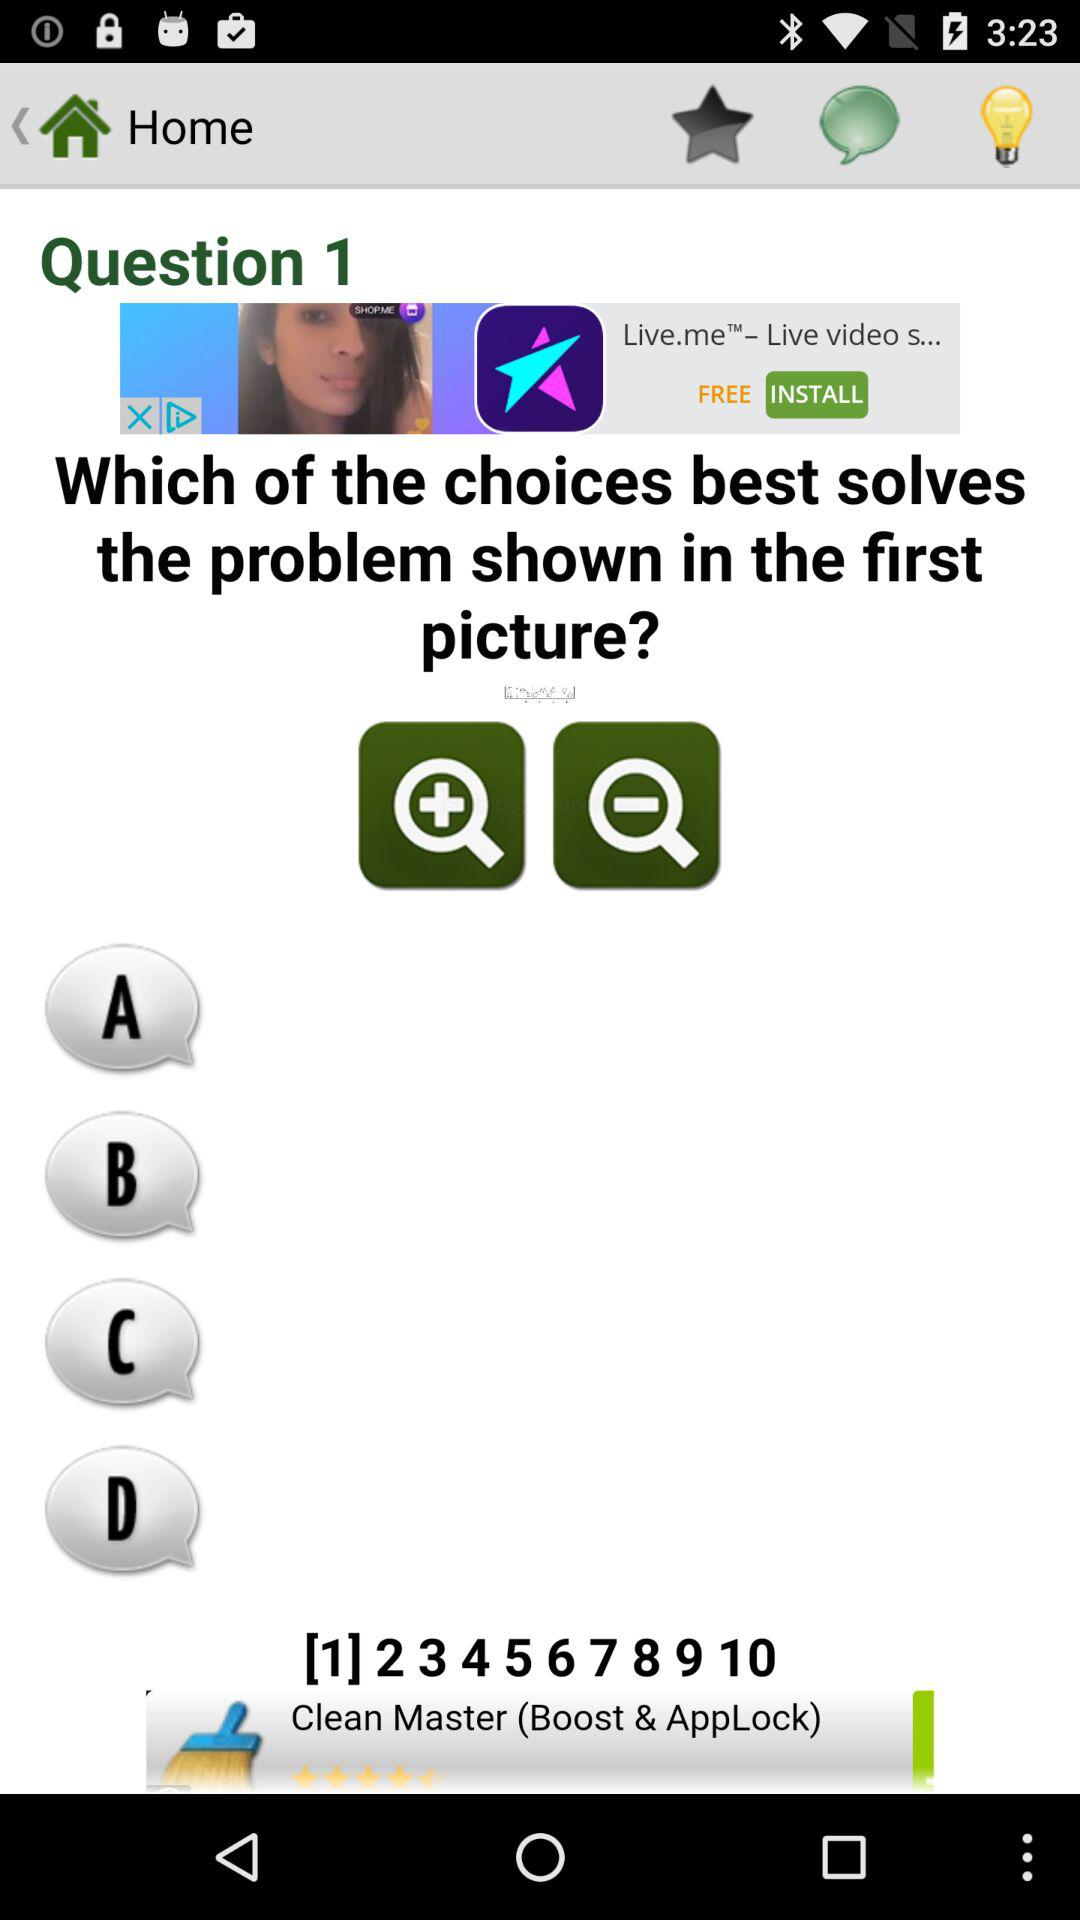How many more magnifying glasses are there than light bulbs?
Answer the question using a single word or phrase. 1 